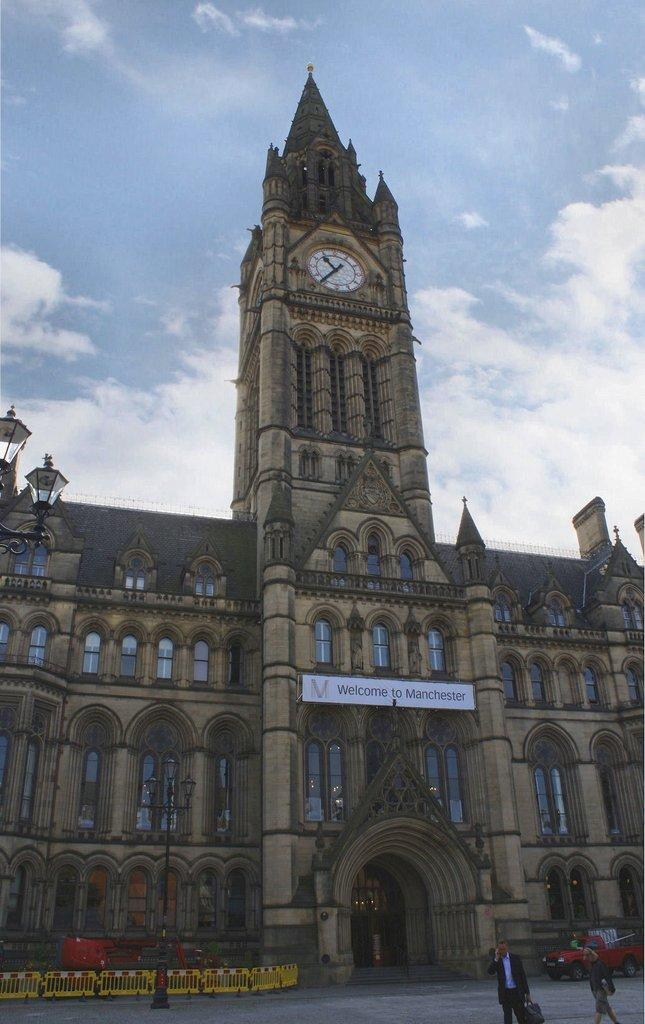What is the main subject in the center of the image? There is a building in the center of the image. What can be seen in the background of the image? There is sky visible in the background of the image, and there are clouds present. Who or what is located at the bottom of the image? There are persons and a vehicle at the bottom of the image. What type of bell can be heard ringing in the image? There is no bell present or ringing in the image. Can you tell me how many territories are visible in the image? The concept of territories is not applicable to this image, as it features a building, sky, clouds, persons, and a vehicle. 